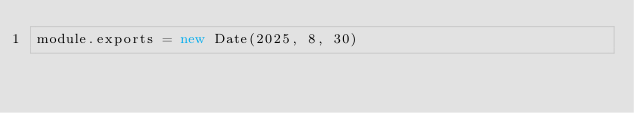<code> <loc_0><loc_0><loc_500><loc_500><_JavaScript_>module.exports = new Date(2025, 8, 30)
</code> 